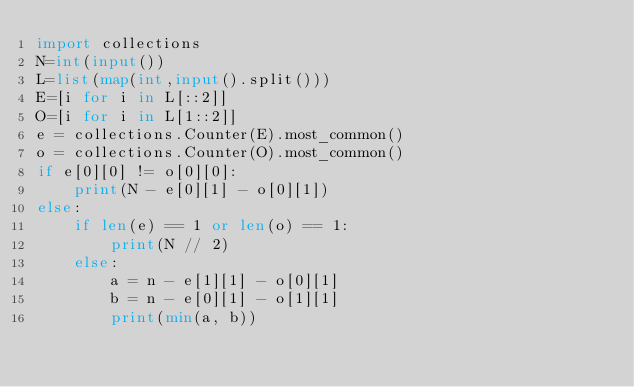Convert code to text. <code><loc_0><loc_0><loc_500><loc_500><_Python_>import collections
N=int(input())
L=list(map(int,input().split()))
E=[i for i in L[::2]]
O=[i for i in L[1::2]]
e = collections.Counter(E).most_common()
o = collections.Counter(O).most_common()
if e[0][0] != o[0][0]:
    print(N - e[0][1] - o[0][1])
else:
    if len(e) == 1 or len(o) == 1:
        print(N // 2)
    else:
        a = n - e[1][1] - o[0][1]
        b = n - e[0][1] - o[1][1]
        print(min(a, b))</code> 